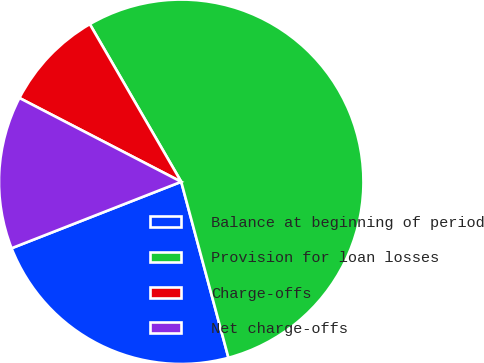<chart> <loc_0><loc_0><loc_500><loc_500><pie_chart><fcel>Balance at beginning of period<fcel>Provision for loan losses<fcel>Charge-offs<fcel>Net charge-offs<nl><fcel>23.23%<fcel>54.19%<fcel>9.03%<fcel>13.55%<nl></chart> 